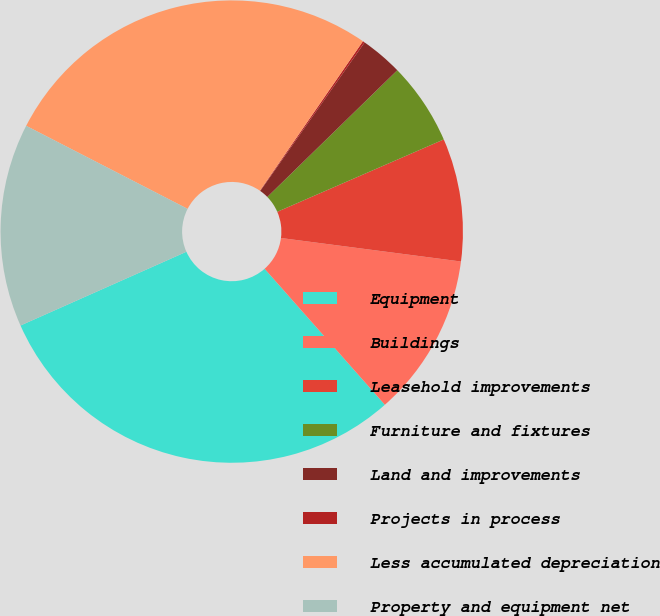<chart> <loc_0><loc_0><loc_500><loc_500><pie_chart><fcel>Equipment<fcel>Buildings<fcel>Leasehold improvements<fcel>Furniture and fixtures<fcel>Land and improvements<fcel>Projects in process<fcel>Less accumulated depreciation<fcel>Property and equipment net<nl><fcel>29.86%<fcel>11.41%<fcel>8.59%<fcel>5.77%<fcel>2.96%<fcel>0.14%<fcel>27.04%<fcel>14.22%<nl></chart> 